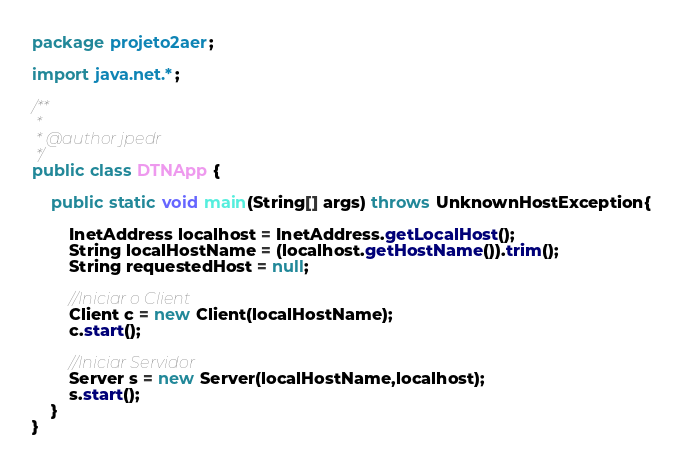<code> <loc_0><loc_0><loc_500><loc_500><_Java_>package projeto2aer;

import java.net.*;

/**
 *
 * @author jpedr
 */
public class DTNApp {
    
    public static void main(String[] args) throws UnknownHostException{
        
        InetAddress localhost = InetAddress.getLocalHost();
        String localHostName = (localhost.getHostName()).trim();
        String requestedHost = null;
        
        //Iniciar o Client
        Client c = new Client(localHostName);
        c.start();
        
        //Iniciar Servidor
        Server s = new Server(localHostName,localhost);
        s.start();
    }   
}
</code> 